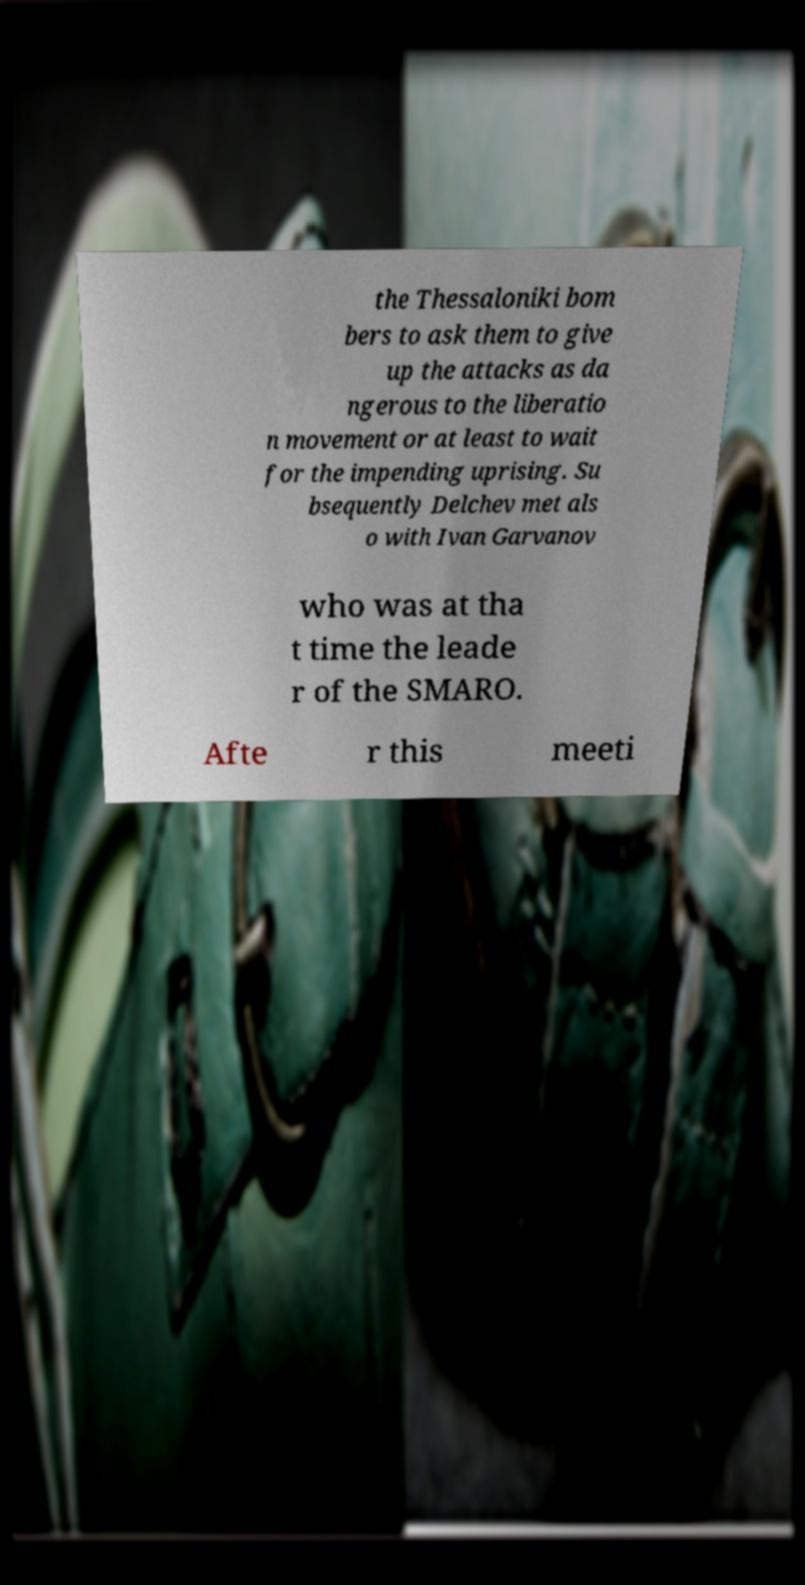For documentation purposes, I need the text within this image transcribed. Could you provide that? the Thessaloniki bom bers to ask them to give up the attacks as da ngerous to the liberatio n movement or at least to wait for the impending uprising. Su bsequently Delchev met als o with Ivan Garvanov who was at tha t time the leade r of the SMARO. Afte r this meeti 